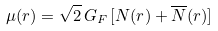Convert formula to latex. <formula><loc_0><loc_0><loc_500><loc_500>\mu ( r ) = \sqrt { 2 } \, G _ { F } \, [ N ( r ) + \overline { N } ( r ) ]</formula> 